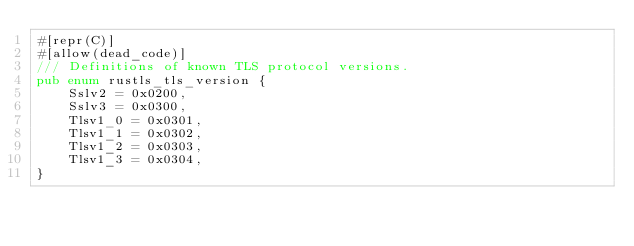<code> <loc_0><loc_0><loc_500><loc_500><_Rust_>#[repr(C)]
#[allow(dead_code)]
/// Definitions of known TLS protocol versions.
pub enum rustls_tls_version {
    Sslv2 = 0x0200,
    Sslv3 = 0x0300,
    Tlsv1_0 = 0x0301,
    Tlsv1_1 = 0x0302,
    Tlsv1_2 = 0x0303,
    Tlsv1_3 = 0x0304,
}
</code> 